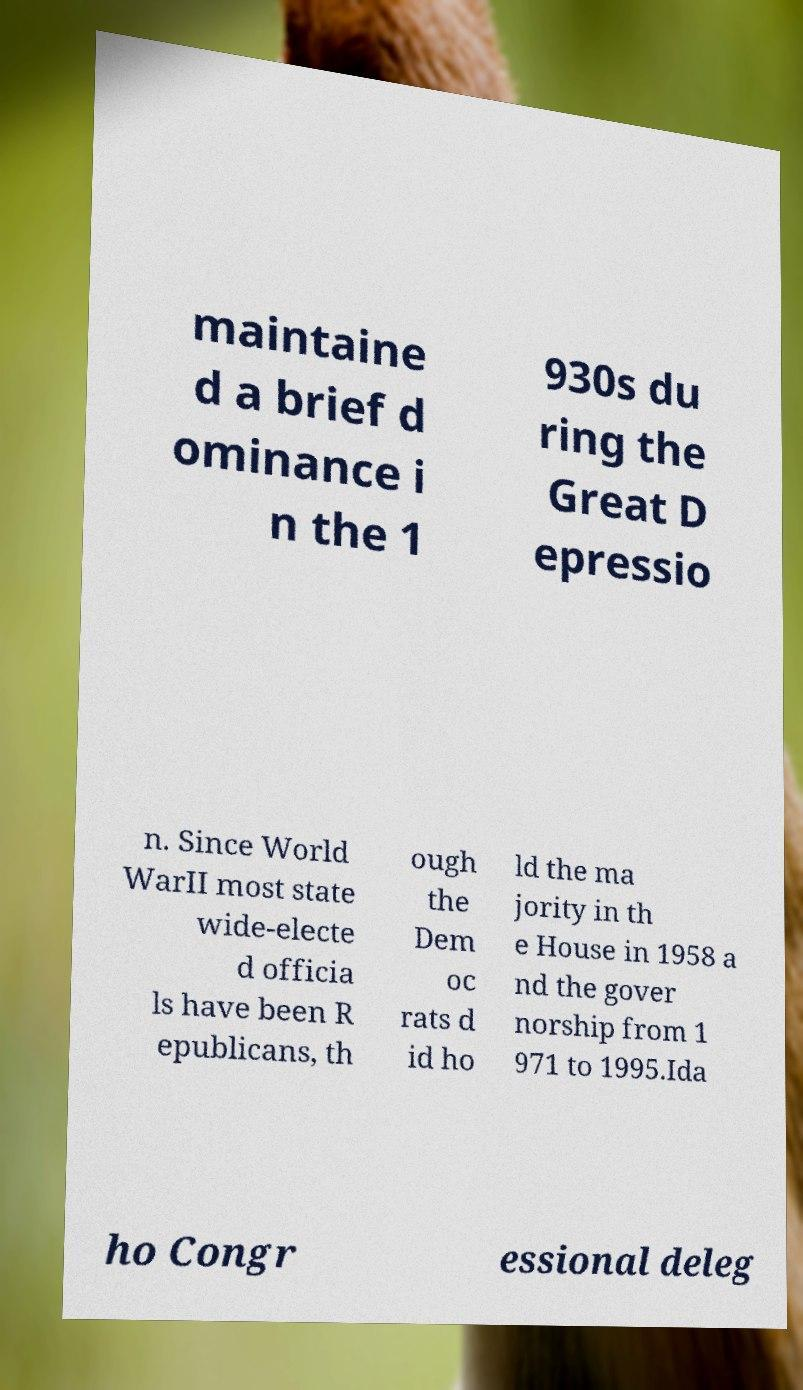Please identify and transcribe the text found in this image. maintaine d a brief d ominance i n the 1 930s du ring the Great D epressio n. Since World WarII most state wide-electe d officia ls have been R epublicans, th ough the Dem oc rats d id ho ld the ma jority in th e House in 1958 a nd the gover norship from 1 971 to 1995.Ida ho Congr essional deleg 